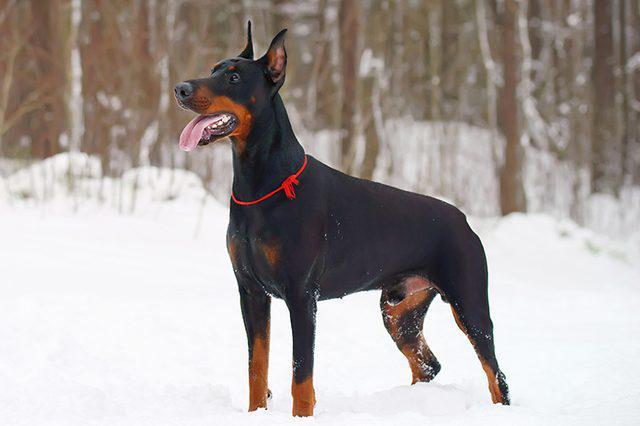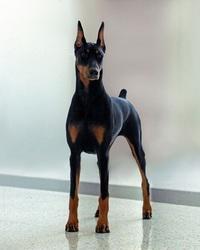The first image is the image on the left, the second image is the image on the right. Examine the images to the left and right. Is the description "Each image contains one doberman with erect ears, and the left image features a doberman standing with its head and body angled leftward." accurate? Answer yes or no. Yes. The first image is the image on the left, the second image is the image on the right. Analyze the images presented: Is the assertion "there is a doberman with a taught leash attached to it's collar" valid? Answer yes or no. No. 